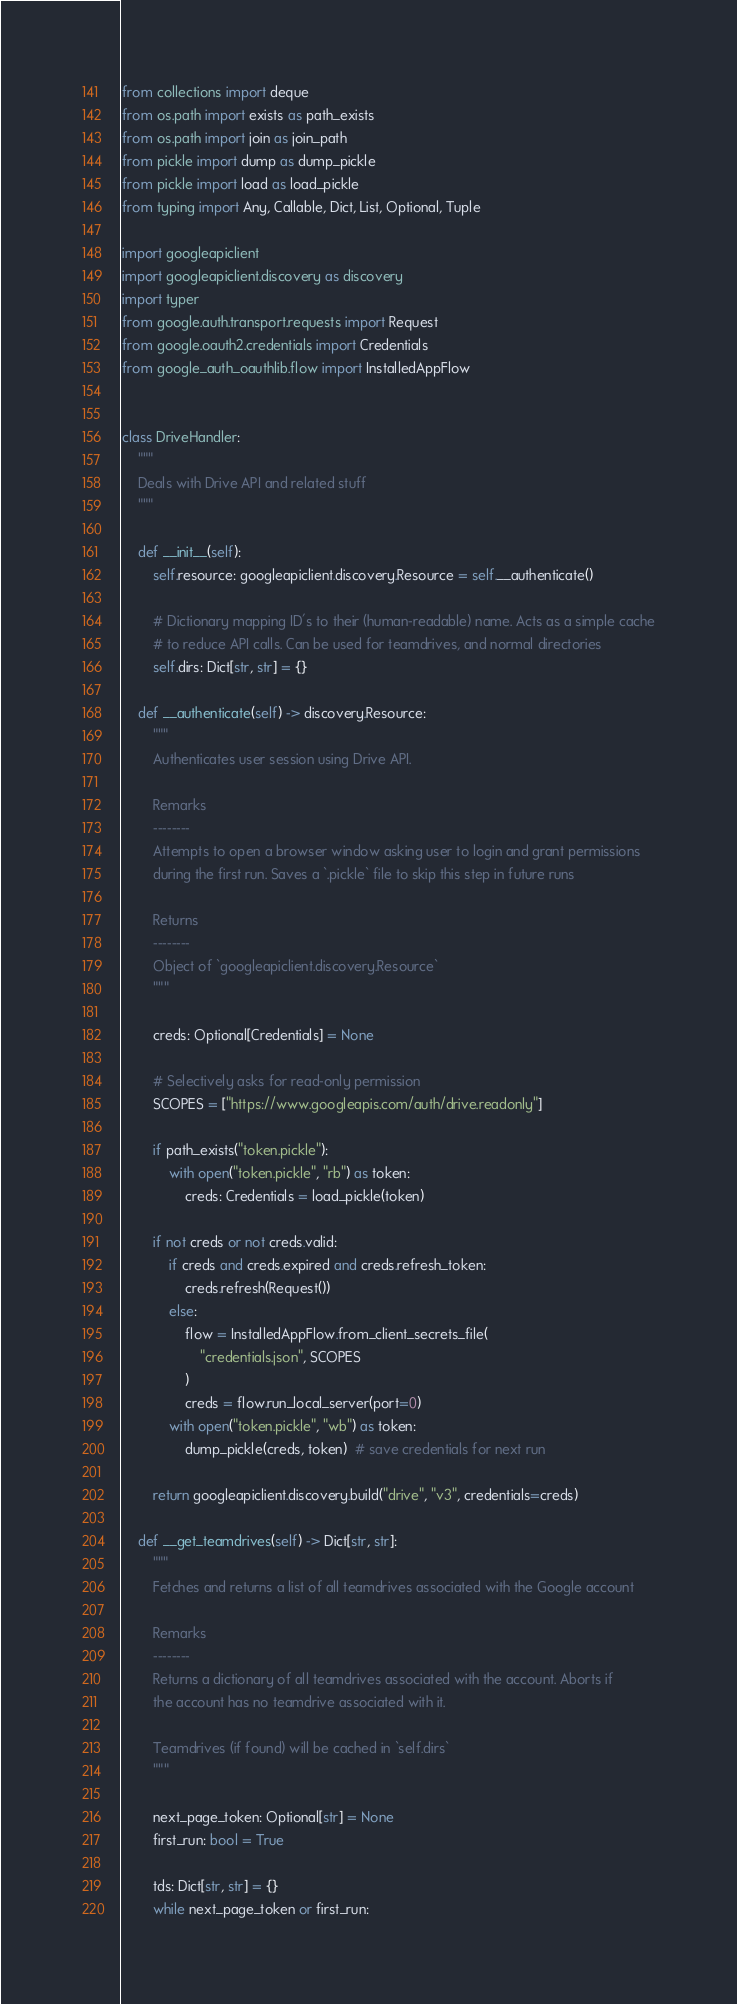Convert code to text. <code><loc_0><loc_0><loc_500><loc_500><_Python_>from collections import deque
from os.path import exists as path_exists
from os.path import join as join_path
from pickle import dump as dump_pickle
from pickle import load as load_pickle
from typing import Any, Callable, Dict, List, Optional, Tuple

import googleapiclient
import googleapiclient.discovery as discovery
import typer
from google.auth.transport.requests import Request
from google.oauth2.credentials import Credentials
from google_auth_oauthlib.flow import InstalledAppFlow


class DriveHandler:
    """
    Deals with Drive API and related stuff
    """

    def __init__(self):
        self.resource: googleapiclient.discovery.Resource = self.__authenticate()

        # Dictionary mapping ID's to their (human-readable) name. Acts as a simple cache
        # to reduce API calls. Can be used for teamdrives, and normal directories
        self.dirs: Dict[str, str] = {}

    def __authenticate(self) -> discovery.Resource:
        """
        Authenticates user session using Drive API.

        Remarks
        --------
        Attempts to open a browser window asking user to login and grant permissions
        during the first run. Saves a `.pickle` file to skip this step in future runs

        Returns
        --------
        Object of `googleapiclient.discovery.Resource`
        """

        creds: Optional[Credentials] = None

        # Selectively asks for read-only permission
        SCOPES = ["https://www.googleapis.com/auth/drive.readonly"]

        if path_exists("token.pickle"):
            with open("token.pickle", "rb") as token:
                creds: Credentials = load_pickle(token)

        if not creds or not creds.valid:
            if creds and creds.expired and creds.refresh_token:
                creds.refresh(Request())
            else:
                flow = InstalledAppFlow.from_client_secrets_file(
                    "credentials.json", SCOPES
                )
                creds = flow.run_local_server(port=0)
            with open("token.pickle", "wb") as token:
                dump_pickle(creds, token)  # save credentials for next run

        return googleapiclient.discovery.build("drive", "v3", credentials=creds)

    def __get_teamdrives(self) -> Dict[str, str]:
        """
        Fetches and returns a list of all teamdrives associated with the Google account

        Remarks
        --------
        Returns a dictionary of all teamdrives associated with the account. Aborts if
        the account has no teamdrive associated with it.

        Teamdrives (if found) will be cached in `self.dirs`
        """

        next_page_token: Optional[str] = None
        first_run: bool = True

        tds: Dict[str, str] = {}
        while next_page_token or first_run:</code> 